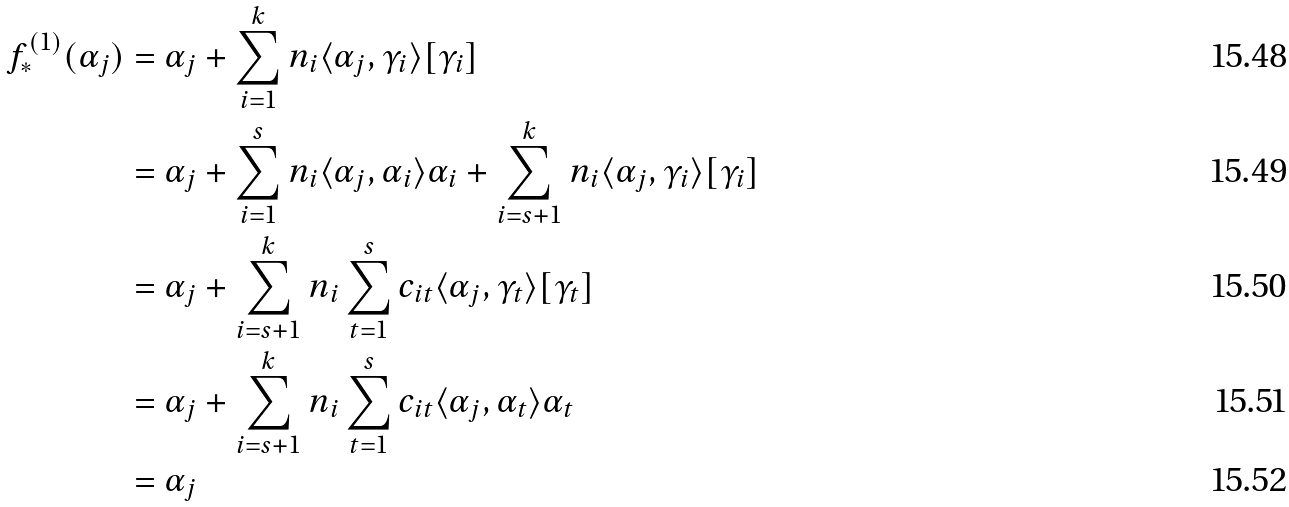Convert formula to latex. <formula><loc_0><loc_0><loc_500><loc_500>f _ { * } ^ { ( 1 ) } ( \alpha _ { j } ) & = \alpha _ { j } + \sum _ { i = 1 } ^ { k } n _ { i } \langle \alpha _ { j } , \gamma _ { i } \rangle [ \gamma _ { i } ] \\ & = \alpha _ { j } + \sum _ { i = 1 } ^ { s } n _ { i } \langle \alpha _ { j } , \alpha _ { i } \rangle \alpha _ { i } + \sum _ { i = s + 1 } ^ { k } n _ { i } \langle \alpha _ { j } , \gamma _ { i } \rangle [ \gamma _ { i } ] \\ & = \alpha _ { j } + \sum _ { i = s + 1 } ^ { k } n _ { i } \sum _ { t = 1 } ^ { s } c _ { i t } \langle \alpha _ { j } , \gamma _ { t } \rangle [ \gamma _ { t } ] \\ & = \alpha _ { j } + \sum _ { i = s + 1 } ^ { k } n _ { i } \sum _ { t = 1 } ^ { s } c _ { i t } \langle \alpha _ { j } , \alpha _ { t } \rangle \alpha _ { t } \\ & = \alpha _ { j }</formula> 